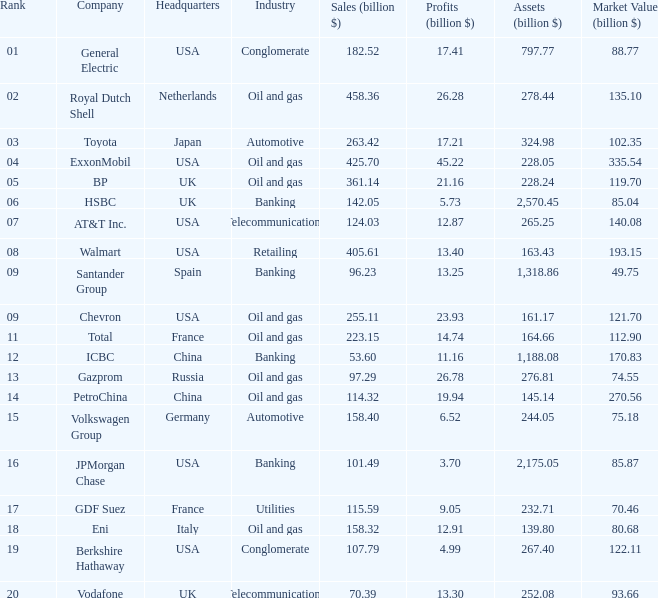Determine the least market value (billion $) having assets (billion $) more than 27 None. 